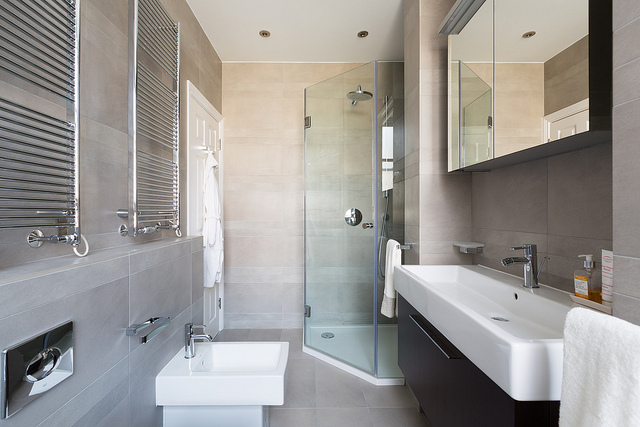Can you describe the elements in this bathroom? Certainly! The image displays a contemporary bathroom equipped with a sleek white bathtub on the right, a shower stall with transparent glass doors in the center, a minimalist style basin to the left, a bidet next to it, and a wall-mounted toilet. There are two gray blinds covering windows, a large rectangular mirror above the sink, and various towels neatly hung or placed throughout the space.  What is the color scheme of this bathroom? The bathroom features a calming color scheme with neutral tones. The walls and floor are tiled in soft beige and gray shades which are complemented by the white fixtures. Accents like the towel and the toiletries add subtle hues to the monochromatic palette. 